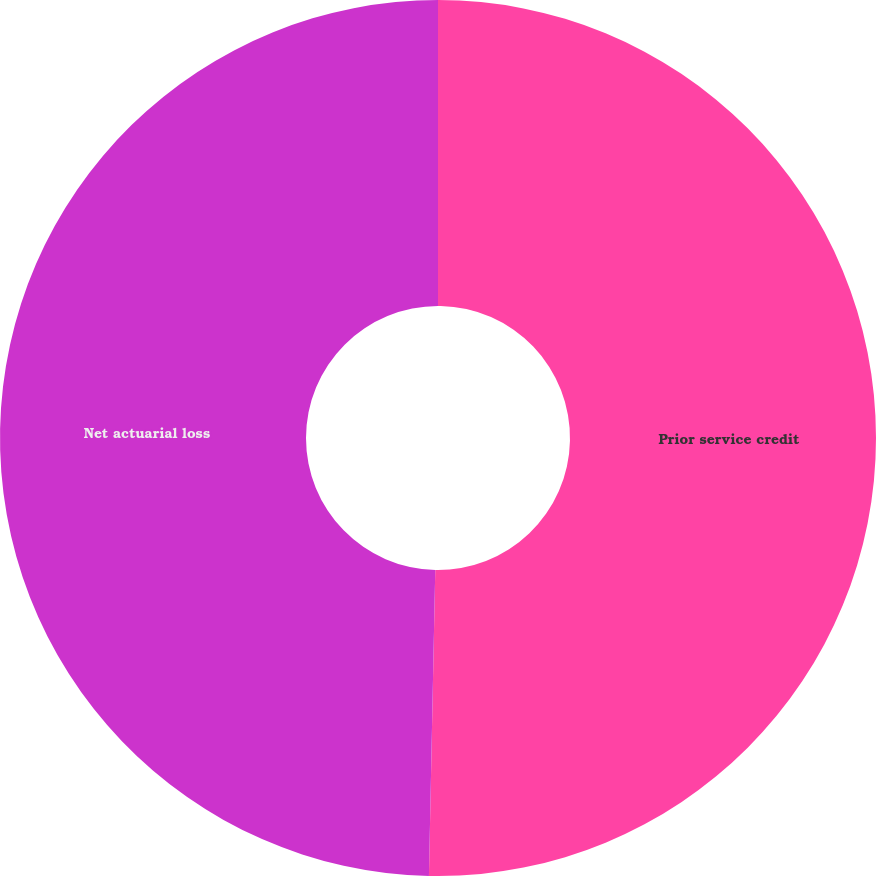<chart> <loc_0><loc_0><loc_500><loc_500><pie_chart><fcel>Prior service credit<fcel>Net actuarial loss<nl><fcel>50.33%<fcel>49.67%<nl></chart> 